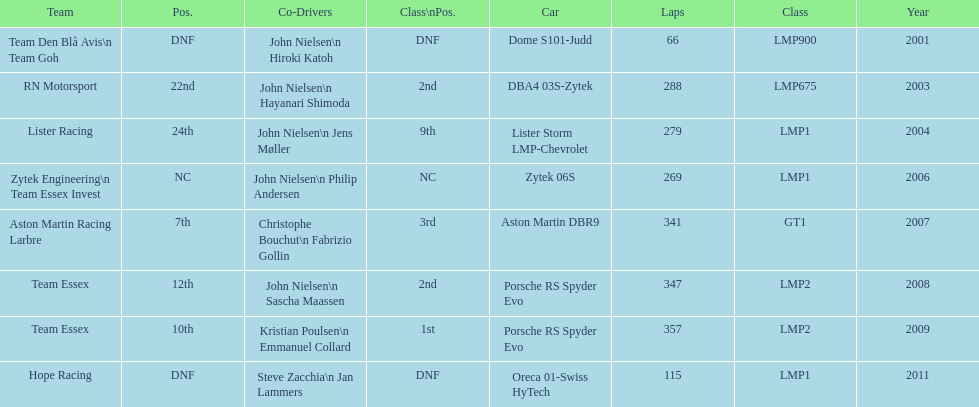Who was john nielsen co-driver for team lister in 2004? Jens Møller. 